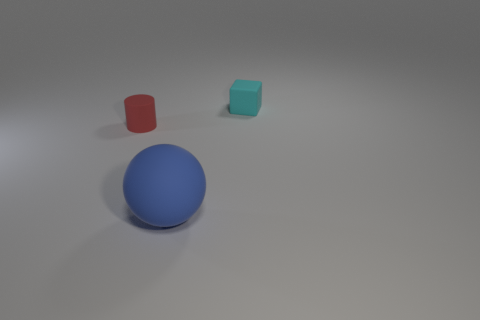Add 1 small cyan rubber things. How many objects exist? 4 Subtract all spheres. How many objects are left? 2 Add 2 rubber objects. How many rubber objects are left? 5 Add 2 red things. How many red things exist? 3 Subtract 0 gray cylinders. How many objects are left? 3 Subtract all large brown cylinders. Subtract all small rubber cylinders. How many objects are left? 2 